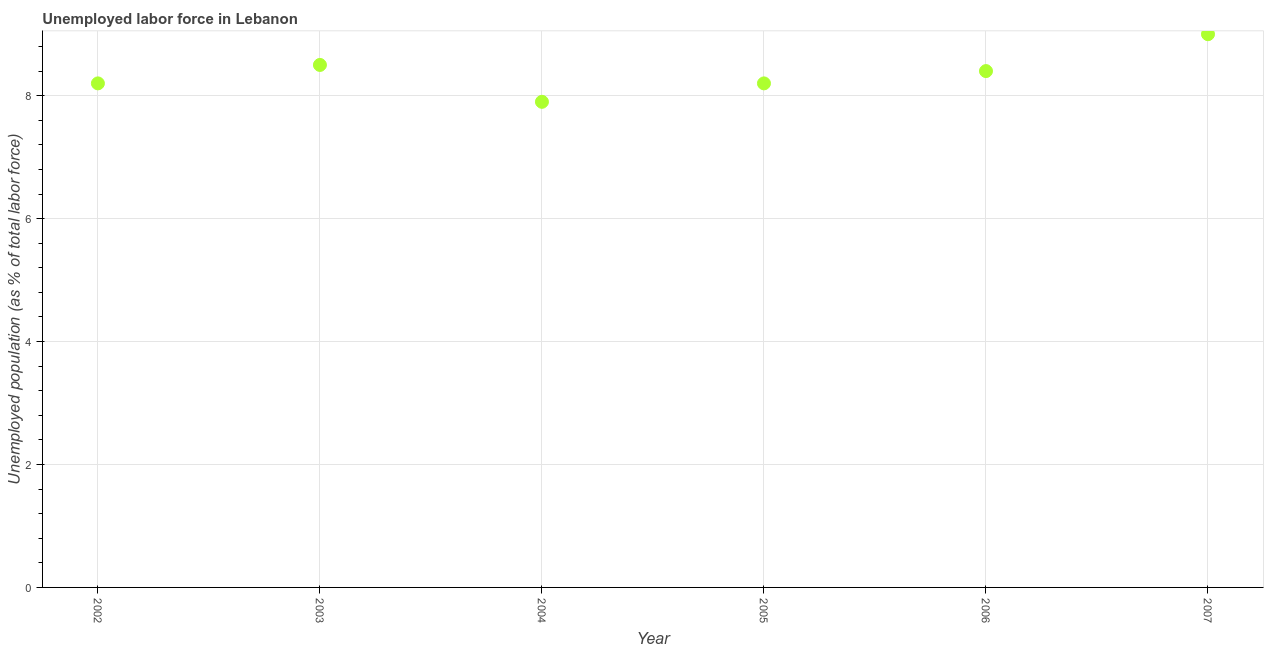What is the total unemployed population in 2003?
Your answer should be compact. 8.5. Across all years, what is the maximum total unemployed population?
Your answer should be compact. 9. Across all years, what is the minimum total unemployed population?
Make the answer very short. 7.9. In which year was the total unemployed population minimum?
Your answer should be very brief. 2004. What is the sum of the total unemployed population?
Ensure brevity in your answer.  50.2. What is the difference between the total unemployed population in 2005 and 2006?
Your response must be concise. -0.2. What is the average total unemployed population per year?
Give a very brief answer. 8.37. What is the median total unemployed population?
Give a very brief answer. 8.3. In how many years, is the total unemployed population greater than 6.4 %?
Provide a short and direct response. 6. Do a majority of the years between 2007 and 2003 (inclusive) have total unemployed population greater than 8 %?
Give a very brief answer. Yes. What is the ratio of the total unemployed population in 2003 to that in 2004?
Your answer should be very brief. 1.08. Is the difference between the total unemployed population in 2003 and 2004 greater than the difference between any two years?
Offer a very short reply. No. Is the sum of the total unemployed population in 2002 and 2006 greater than the maximum total unemployed population across all years?
Provide a short and direct response. Yes. What is the difference between the highest and the lowest total unemployed population?
Your answer should be compact. 1.1. In how many years, is the total unemployed population greater than the average total unemployed population taken over all years?
Offer a very short reply. 3. How many dotlines are there?
Your answer should be compact. 1. How many years are there in the graph?
Offer a terse response. 6. Are the values on the major ticks of Y-axis written in scientific E-notation?
Give a very brief answer. No. What is the title of the graph?
Offer a very short reply. Unemployed labor force in Lebanon. What is the label or title of the Y-axis?
Offer a very short reply. Unemployed population (as % of total labor force). What is the Unemployed population (as % of total labor force) in 2002?
Give a very brief answer. 8.2. What is the Unemployed population (as % of total labor force) in 2003?
Ensure brevity in your answer.  8.5. What is the Unemployed population (as % of total labor force) in 2004?
Offer a terse response. 7.9. What is the Unemployed population (as % of total labor force) in 2005?
Your response must be concise. 8.2. What is the Unemployed population (as % of total labor force) in 2006?
Provide a short and direct response. 8.4. What is the difference between the Unemployed population (as % of total labor force) in 2002 and 2006?
Keep it short and to the point. -0.2. What is the difference between the Unemployed population (as % of total labor force) in 2002 and 2007?
Ensure brevity in your answer.  -0.8. What is the difference between the Unemployed population (as % of total labor force) in 2003 and 2007?
Ensure brevity in your answer.  -0.5. What is the difference between the Unemployed population (as % of total labor force) in 2004 and 2006?
Your answer should be compact. -0.5. What is the difference between the Unemployed population (as % of total labor force) in 2004 and 2007?
Offer a terse response. -1.1. What is the difference between the Unemployed population (as % of total labor force) in 2006 and 2007?
Ensure brevity in your answer.  -0.6. What is the ratio of the Unemployed population (as % of total labor force) in 2002 to that in 2004?
Ensure brevity in your answer.  1.04. What is the ratio of the Unemployed population (as % of total labor force) in 2002 to that in 2006?
Make the answer very short. 0.98. What is the ratio of the Unemployed population (as % of total labor force) in 2002 to that in 2007?
Your response must be concise. 0.91. What is the ratio of the Unemployed population (as % of total labor force) in 2003 to that in 2004?
Offer a very short reply. 1.08. What is the ratio of the Unemployed population (as % of total labor force) in 2003 to that in 2005?
Provide a succinct answer. 1.04. What is the ratio of the Unemployed population (as % of total labor force) in 2003 to that in 2006?
Ensure brevity in your answer.  1.01. What is the ratio of the Unemployed population (as % of total labor force) in 2003 to that in 2007?
Give a very brief answer. 0.94. What is the ratio of the Unemployed population (as % of total labor force) in 2004 to that in 2005?
Your answer should be compact. 0.96. What is the ratio of the Unemployed population (as % of total labor force) in 2004 to that in 2007?
Make the answer very short. 0.88. What is the ratio of the Unemployed population (as % of total labor force) in 2005 to that in 2006?
Ensure brevity in your answer.  0.98. What is the ratio of the Unemployed population (as % of total labor force) in 2005 to that in 2007?
Provide a succinct answer. 0.91. What is the ratio of the Unemployed population (as % of total labor force) in 2006 to that in 2007?
Offer a terse response. 0.93. 